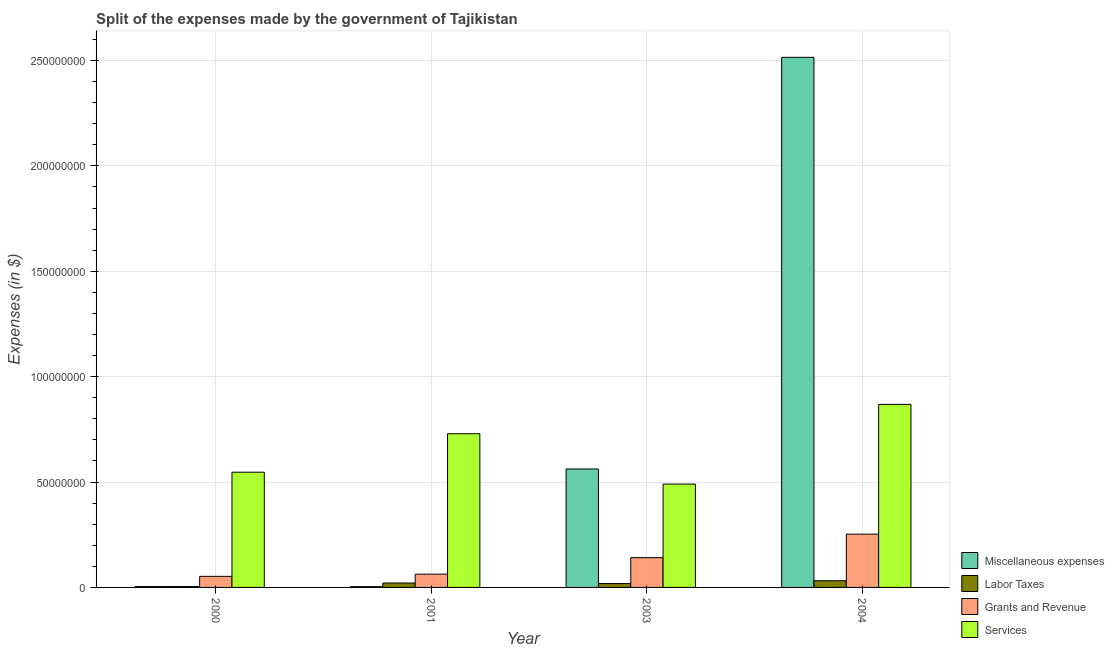How many different coloured bars are there?
Provide a succinct answer. 4. How many groups of bars are there?
Make the answer very short. 4. Are the number of bars per tick equal to the number of legend labels?
Offer a very short reply. Yes. Are the number of bars on each tick of the X-axis equal?
Keep it short and to the point. Yes. How many bars are there on the 4th tick from the right?
Your answer should be very brief. 4. In how many cases, is the number of bars for a given year not equal to the number of legend labels?
Provide a short and direct response. 0. What is the amount spent on services in 2003?
Provide a succinct answer. 4.90e+07. Across all years, what is the maximum amount spent on services?
Offer a terse response. 8.68e+07. Across all years, what is the minimum amount spent on labor taxes?
Provide a succinct answer. 4.11e+05. What is the total amount spent on labor taxes in the graph?
Offer a terse response. 7.50e+06. What is the difference between the amount spent on miscellaneous expenses in 2000 and that in 2004?
Give a very brief answer. -2.51e+08. What is the difference between the amount spent on miscellaneous expenses in 2001 and the amount spent on services in 2000?
Provide a short and direct response. -2.50e+04. What is the average amount spent on services per year?
Provide a short and direct response. 6.59e+07. In the year 2004, what is the difference between the amount spent on services and amount spent on labor taxes?
Provide a short and direct response. 0. What is the ratio of the amount spent on grants and revenue in 2001 to that in 2004?
Make the answer very short. 0.25. Is the difference between the amount spent on labor taxes in 2003 and 2004 greater than the difference between the amount spent on miscellaneous expenses in 2003 and 2004?
Your answer should be very brief. No. What is the difference between the highest and the second highest amount spent on services?
Make the answer very short. 1.39e+07. What is the difference between the highest and the lowest amount spent on labor taxes?
Provide a short and direct response. 2.76e+06. In how many years, is the amount spent on services greater than the average amount spent on services taken over all years?
Ensure brevity in your answer.  2. Is it the case that in every year, the sum of the amount spent on labor taxes and amount spent on grants and revenue is greater than the sum of amount spent on services and amount spent on miscellaneous expenses?
Your answer should be compact. No. What does the 3rd bar from the left in 2000 represents?
Your answer should be very brief. Grants and Revenue. What does the 2nd bar from the right in 2000 represents?
Ensure brevity in your answer.  Grants and Revenue. How many bars are there?
Provide a short and direct response. 16. What is the difference between two consecutive major ticks on the Y-axis?
Provide a short and direct response. 5.00e+07. Where does the legend appear in the graph?
Offer a terse response. Bottom right. How many legend labels are there?
Your answer should be very brief. 4. How are the legend labels stacked?
Your answer should be compact. Vertical. What is the title of the graph?
Ensure brevity in your answer.  Split of the expenses made by the government of Tajikistan. What is the label or title of the X-axis?
Ensure brevity in your answer.  Year. What is the label or title of the Y-axis?
Offer a terse response. Expenses (in $). What is the Expenses (in $) in Miscellaneous expenses in 2000?
Provide a succinct answer. 3.95e+05. What is the Expenses (in $) of Labor Taxes in 2000?
Provide a short and direct response. 4.11e+05. What is the Expenses (in $) in Grants and Revenue in 2000?
Keep it short and to the point. 5.25e+06. What is the Expenses (in $) of Services in 2000?
Offer a terse response. 5.47e+07. What is the Expenses (in $) in Miscellaneous expenses in 2001?
Keep it short and to the point. 3.70e+05. What is the Expenses (in $) of Labor Taxes in 2001?
Keep it short and to the point. 2.09e+06. What is the Expenses (in $) of Grants and Revenue in 2001?
Ensure brevity in your answer.  6.30e+06. What is the Expenses (in $) in Services in 2001?
Offer a very short reply. 7.29e+07. What is the Expenses (in $) in Miscellaneous expenses in 2003?
Give a very brief answer. 5.62e+07. What is the Expenses (in $) in Labor Taxes in 2003?
Offer a very short reply. 1.83e+06. What is the Expenses (in $) of Grants and Revenue in 2003?
Keep it short and to the point. 1.41e+07. What is the Expenses (in $) of Services in 2003?
Provide a short and direct response. 4.90e+07. What is the Expenses (in $) of Miscellaneous expenses in 2004?
Provide a succinct answer. 2.51e+08. What is the Expenses (in $) in Labor Taxes in 2004?
Make the answer very short. 3.17e+06. What is the Expenses (in $) in Grants and Revenue in 2004?
Offer a terse response. 2.53e+07. What is the Expenses (in $) in Services in 2004?
Your answer should be very brief. 8.68e+07. Across all years, what is the maximum Expenses (in $) of Miscellaneous expenses?
Make the answer very short. 2.51e+08. Across all years, what is the maximum Expenses (in $) in Labor Taxes?
Your answer should be compact. 3.17e+06. Across all years, what is the maximum Expenses (in $) in Grants and Revenue?
Offer a very short reply. 2.53e+07. Across all years, what is the maximum Expenses (in $) in Services?
Your answer should be compact. 8.68e+07. Across all years, what is the minimum Expenses (in $) of Labor Taxes?
Keep it short and to the point. 4.11e+05. Across all years, what is the minimum Expenses (in $) in Grants and Revenue?
Make the answer very short. 5.25e+06. Across all years, what is the minimum Expenses (in $) of Services?
Ensure brevity in your answer.  4.90e+07. What is the total Expenses (in $) in Miscellaneous expenses in the graph?
Offer a terse response. 3.08e+08. What is the total Expenses (in $) in Labor Taxes in the graph?
Provide a succinct answer. 7.50e+06. What is the total Expenses (in $) in Grants and Revenue in the graph?
Ensure brevity in your answer.  5.10e+07. What is the total Expenses (in $) in Services in the graph?
Give a very brief answer. 2.63e+08. What is the difference between the Expenses (in $) in Miscellaneous expenses in 2000 and that in 2001?
Offer a very short reply. 2.50e+04. What is the difference between the Expenses (in $) of Labor Taxes in 2000 and that in 2001?
Your response must be concise. -1.68e+06. What is the difference between the Expenses (in $) of Grants and Revenue in 2000 and that in 2001?
Your response must be concise. -1.05e+06. What is the difference between the Expenses (in $) of Services in 2000 and that in 2001?
Ensure brevity in your answer.  -1.82e+07. What is the difference between the Expenses (in $) in Miscellaneous expenses in 2000 and that in 2003?
Your answer should be compact. -5.58e+07. What is the difference between the Expenses (in $) of Labor Taxes in 2000 and that in 2003?
Provide a short and direct response. -1.42e+06. What is the difference between the Expenses (in $) of Grants and Revenue in 2000 and that in 2003?
Your answer should be compact. -8.87e+06. What is the difference between the Expenses (in $) of Services in 2000 and that in 2003?
Provide a short and direct response. 5.65e+06. What is the difference between the Expenses (in $) of Miscellaneous expenses in 2000 and that in 2004?
Ensure brevity in your answer.  -2.51e+08. What is the difference between the Expenses (in $) of Labor Taxes in 2000 and that in 2004?
Offer a very short reply. -2.76e+06. What is the difference between the Expenses (in $) of Grants and Revenue in 2000 and that in 2004?
Ensure brevity in your answer.  -2.00e+07. What is the difference between the Expenses (in $) in Services in 2000 and that in 2004?
Provide a succinct answer. -3.22e+07. What is the difference between the Expenses (in $) in Miscellaneous expenses in 2001 and that in 2003?
Ensure brevity in your answer.  -5.58e+07. What is the difference between the Expenses (in $) of Labor Taxes in 2001 and that in 2003?
Give a very brief answer. 2.58e+05. What is the difference between the Expenses (in $) in Grants and Revenue in 2001 and that in 2003?
Your answer should be compact. -7.82e+06. What is the difference between the Expenses (in $) of Services in 2001 and that in 2003?
Give a very brief answer. 2.39e+07. What is the difference between the Expenses (in $) in Miscellaneous expenses in 2001 and that in 2004?
Make the answer very short. -2.51e+08. What is the difference between the Expenses (in $) in Labor Taxes in 2001 and that in 2004?
Keep it short and to the point. -1.08e+06. What is the difference between the Expenses (in $) of Grants and Revenue in 2001 and that in 2004?
Keep it short and to the point. -1.90e+07. What is the difference between the Expenses (in $) in Services in 2001 and that in 2004?
Ensure brevity in your answer.  -1.39e+07. What is the difference between the Expenses (in $) in Miscellaneous expenses in 2003 and that in 2004?
Ensure brevity in your answer.  -1.95e+08. What is the difference between the Expenses (in $) of Labor Taxes in 2003 and that in 2004?
Give a very brief answer. -1.34e+06. What is the difference between the Expenses (in $) in Grants and Revenue in 2003 and that in 2004?
Keep it short and to the point. -1.12e+07. What is the difference between the Expenses (in $) in Services in 2003 and that in 2004?
Your response must be concise. -3.78e+07. What is the difference between the Expenses (in $) in Miscellaneous expenses in 2000 and the Expenses (in $) in Labor Taxes in 2001?
Your response must be concise. -1.69e+06. What is the difference between the Expenses (in $) of Miscellaneous expenses in 2000 and the Expenses (in $) of Grants and Revenue in 2001?
Your response must be concise. -5.90e+06. What is the difference between the Expenses (in $) of Miscellaneous expenses in 2000 and the Expenses (in $) of Services in 2001?
Your answer should be very brief. -7.25e+07. What is the difference between the Expenses (in $) of Labor Taxes in 2000 and the Expenses (in $) of Grants and Revenue in 2001?
Provide a short and direct response. -5.89e+06. What is the difference between the Expenses (in $) in Labor Taxes in 2000 and the Expenses (in $) in Services in 2001?
Your answer should be compact. -7.25e+07. What is the difference between the Expenses (in $) of Grants and Revenue in 2000 and the Expenses (in $) of Services in 2001?
Give a very brief answer. -6.77e+07. What is the difference between the Expenses (in $) of Miscellaneous expenses in 2000 and the Expenses (in $) of Labor Taxes in 2003?
Make the answer very short. -1.43e+06. What is the difference between the Expenses (in $) of Miscellaneous expenses in 2000 and the Expenses (in $) of Grants and Revenue in 2003?
Provide a succinct answer. -1.37e+07. What is the difference between the Expenses (in $) in Miscellaneous expenses in 2000 and the Expenses (in $) in Services in 2003?
Give a very brief answer. -4.86e+07. What is the difference between the Expenses (in $) in Labor Taxes in 2000 and the Expenses (in $) in Grants and Revenue in 2003?
Give a very brief answer. -1.37e+07. What is the difference between the Expenses (in $) of Labor Taxes in 2000 and the Expenses (in $) of Services in 2003?
Your answer should be very brief. -4.86e+07. What is the difference between the Expenses (in $) in Grants and Revenue in 2000 and the Expenses (in $) in Services in 2003?
Make the answer very short. -4.38e+07. What is the difference between the Expenses (in $) in Miscellaneous expenses in 2000 and the Expenses (in $) in Labor Taxes in 2004?
Your answer should be very brief. -2.78e+06. What is the difference between the Expenses (in $) in Miscellaneous expenses in 2000 and the Expenses (in $) in Grants and Revenue in 2004?
Make the answer very short. -2.49e+07. What is the difference between the Expenses (in $) of Miscellaneous expenses in 2000 and the Expenses (in $) of Services in 2004?
Give a very brief answer. -8.64e+07. What is the difference between the Expenses (in $) in Labor Taxes in 2000 and the Expenses (in $) in Grants and Revenue in 2004?
Offer a very short reply. -2.49e+07. What is the difference between the Expenses (in $) in Labor Taxes in 2000 and the Expenses (in $) in Services in 2004?
Give a very brief answer. -8.64e+07. What is the difference between the Expenses (in $) of Grants and Revenue in 2000 and the Expenses (in $) of Services in 2004?
Give a very brief answer. -8.16e+07. What is the difference between the Expenses (in $) in Miscellaneous expenses in 2001 and the Expenses (in $) in Labor Taxes in 2003?
Give a very brief answer. -1.46e+06. What is the difference between the Expenses (in $) of Miscellaneous expenses in 2001 and the Expenses (in $) of Grants and Revenue in 2003?
Your response must be concise. -1.38e+07. What is the difference between the Expenses (in $) in Miscellaneous expenses in 2001 and the Expenses (in $) in Services in 2003?
Keep it short and to the point. -4.86e+07. What is the difference between the Expenses (in $) of Labor Taxes in 2001 and the Expenses (in $) of Grants and Revenue in 2003?
Ensure brevity in your answer.  -1.20e+07. What is the difference between the Expenses (in $) of Labor Taxes in 2001 and the Expenses (in $) of Services in 2003?
Your answer should be compact. -4.69e+07. What is the difference between the Expenses (in $) in Grants and Revenue in 2001 and the Expenses (in $) in Services in 2003?
Offer a terse response. -4.27e+07. What is the difference between the Expenses (in $) of Miscellaneous expenses in 2001 and the Expenses (in $) of Labor Taxes in 2004?
Your answer should be very brief. -2.80e+06. What is the difference between the Expenses (in $) in Miscellaneous expenses in 2001 and the Expenses (in $) in Grants and Revenue in 2004?
Ensure brevity in your answer.  -2.49e+07. What is the difference between the Expenses (in $) in Miscellaneous expenses in 2001 and the Expenses (in $) in Services in 2004?
Provide a short and direct response. -8.65e+07. What is the difference between the Expenses (in $) in Labor Taxes in 2001 and the Expenses (in $) in Grants and Revenue in 2004?
Your response must be concise. -2.32e+07. What is the difference between the Expenses (in $) in Labor Taxes in 2001 and the Expenses (in $) in Services in 2004?
Provide a short and direct response. -8.48e+07. What is the difference between the Expenses (in $) of Grants and Revenue in 2001 and the Expenses (in $) of Services in 2004?
Offer a very short reply. -8.05e+07. What is the difference between the Expenses (in $) in Miscellaneous expenses in 2003 and the Expenses (in $) in Labor Taxes in 2004?
Your answer should be very brief. 5.30e+07. What is the difference between the Expenses (in $) in Miscellaneous expenses in 2003 and the Expenses (in $) in Grants and Revenue in 2004?
Your answer should be compact. 3.09e+07. What is the difference between the Expenses (in $) of Miscellaneous expenses in 2003 and the Expenses (in $) of Services in 2004?
Ensure brevity in your answer.  -3.07e+07. What is the difference between the Expenses (in $) of Labor Taxes in 2003 and the Expenses (in $) of Grants and Revenue in 2004?
Keep it short and to the point. -2.34e+07. What is the difference between the Expenses (in $) of Labor Taxes in 2003 and the Expenses (in $) of Services in 2004?
Provide a succinct answer. -8.50e+07. What is the difference between the Expenses (in $) in Grants and Revenue in 2003 and the Expenses (in $) in Services in 2004?
Give a very brief answer. -7.27e+07. What is the average Expenses (in $) in Miscellaneous expenses per year?
Provide a short and direct response. 7.71e+07. What is the average Expenses (in $) of Labor Taxes per year?
Offer a very short reply. 1.87e+06. What is the average Expenses (in $) of Grants and Revenue per year?
Your answer should be very brief. 1.27e+07. What is the average Expenses (in $) in Services per year?
Keep it short and to the point. 6.59e+07. In the year 2000, what is the difference between the Expenses (in $) of Miscellaneous expenses and Expenses (in $) of Labor Taxes?
Your response must be concise. -1.60e+04. In the year 2000, what is the difference between the Expenses (in $) in Miscellaneous expenses and Expenses (in $) in Grants and Revenue?
Keep it short and to the point. -4.86e+06. In the year 2000, what is the difference between the Expenses (in $) in Miscellaneous expenses and Expenses (in $) in Services?
Make the answer very short. -5.43e+07. In the year 2000, what is the difference between the Expenses (in $) in Labor Taxes and Expenses (in $) in Grants and Revenue?
Provide a short and direct response. -4.84e+06. In the year 2000, what is the difference between the Expenses (in $) in Labor Taxes and Expenses (in $) in Services?
Offer a very short reply. -5.43e+07. In the year 2000, what is the difference between the Expenses (in $) in Grants and Revenue and Expenses (in $) in Services?
Keep it short and to the point. -4.94e+07. In the year 2001, what is the difference between the Expenses (in $) of Miscellaneous expenses and Expenses (in $) of Labor Taxes?
Your response must be concise. -1.72e+06. In the year 2001, what is the difference between the Expenses (in $) in Miscellaneous expenses and Expenses (in $) in Grants and Revenue?
Your answer should be compact. -5.93e+06. In the year 2001, what is the difference between the Expenses (in $) of Miscellaneous expenses and Expenses (in $) of Services?
Provide a short and direct response. -7.25e+07. In the year 2001, what is the difference between the Expenses (in $) in Labor Taxes and Expenses (in $) in Grants and Revenue?
Offer a terse response. -4.21e+06. In the year 2001, what is the difference between the Expenses (in $) of Labor Taxes and Expenses (in $) of Services?
Provide a short and direct response. -7.08e+07. In the year 2001, what is the difference between the Expenses (in $) in Grants and Revenue and Expenses (in $) in Services?
Provide a succinct answer. -6.66e+07. In the year 2003, what is the difference between the Expenses (in $) of Miscellaneous expenses and Expenses (in $) of Labor Taxes?
Ensure brevity in your answer.  5.44e+07. In the year 2003, what is the difference between the Expenses (in $) in Miscellaneous expenses and Expenses (in $) in Grants and Revenue?
Offer a very short reply. 4.21e+07. In the year 2003, what is the difference between the Expenses (in $) in Miscellaneous expenses and Expenses (in $) in Services?
Give a very brief answer. 7.16e+06. In the year 2003, what is the difference between the Expenses (in $) in Labor Taxes and Expenses (in $) in Grants and Revenue?
Provide a succinct answer. -1.23e+07. In the year 2003, what is the difference between the Expenses (in $) in Labor Taxes and Expenses (in $) in Services?
Your response must be concise. -4.72e+07. In the year 2003, what is the difference between the Expenses (in $) of Grants and Revenue and Expenses (in $) of Services?
Provide a succinct answer. -3.49e+07. In the year 2004, what is the difference between the Expenses (in $) in Miscellaneous expenses and Expenses (in $) in Labor Taxes?
Keep it short and to the point. 2.48e+08. In the year 2004, what is the difference between the Expenses (in $) of Miscellaneous expenses and Expenses (in $) of Grants and Revenue?
Make the answer very short. 2.26e+08. In the year 2004, what is the difference between the Expenses (in $) in Miscellaneous expenses and Expenses (in $) in Services?
Offer a very short reply. 1.65e+08. In the year 2004, what is the difference between the Expenses (in $) in Labor Taxes and Expenses (in $) in Grants and Revenue?
Keep it short and to the point. -2.21e+07. In the year 2004, what is the difference between the Expenses (in $) in Labor Taxes and Expenses (in $) in Services?
Provide a short and direct response. -8.37e+07. In the year 2004, what is the difference between the Expenses (in $) of Grants and Revenue and Expenses (in $) of Services?
Provide a short and direct response. -6.16e+07. What is the ratio of the Expenses (in $) in Miscellaneous expenses in 2000 to that in 2001?
Your answer should be very brief. 1.07. What is the ratio of the Expenses (in $) of Labor Taxes in 2000 to that in 2001?
Provide a succinct answer. 0.2. What is the ratio of the Expenses (in $) of Grants and Revenue in 2000 to that in 2001?
Give a very brief answer. 0.83. What is the ratio of the Expenses (in $) of Services in 2000 to that in 2001?
Provide a succinct answer. 0.75. What is the ratio of the Expenses (in $) of Miscellaneous expenses in 2000 to that in 2003?
Provide a succinct answer. 0.01. What is the ratio of the Expenses (in $) of Labor Taxes in 2000 to that in 2003?
Offer a terse response. 0.22. What is the ratio of the Expenses (in $) of Grants and Revenue in 2000 to that in 2003?
Your response must be concise. 0.37. What is the ratio of the Expenses (in $) in Services in 2000 to that in 2003?
Provide a succinct answer. 1.12. What is the ratio of the Expenses (in $) in Miscellaneous expenses in 2000 to that in 2004?
Provide a short and direct response. 0. What is the ratio of the Expenses (in $) in Labor Taxes in 2000 to that in 2004?
Make the answer very short. 0.13. What is the ratio of the Expenses (in $) of Grants and Revenue in 2000 to that in 2004?
Your answer should be very brief. 0.21. What is the ratio of the Expenses (in $) of Services in 2000 to that in 2004?
Make the answer very short. 0.63. What is the ratio of the Expenses (in $) of Miscellaneous expenses in 2001 to that in 2003?
Your response must be concise. 0.01. What is the ratio of the Expenses (in $) in Labor Taxes in 2001 to that in 2003?
Ensure brevity in your answer.  1.14. What is the ratio of the Expenses (in $) of Grants and Revenue in 2001 to that in 2003?
Your response must be concise. 0.45. What is the ratio of the Expenses (in $) in Services in 2001 to that in 2003?
Keep it short and to the point. 1.49. What is the ratio of the Expenses (in $) in Miscellaneous expenses in 2001 to that in 2004?
Provide a succinct answer. 0. What is the ratio of the Expenses (in $) in Labor Taxes in 2001 to that in 2004?
Your answer should be compact. 0.66. What is the ratio of the Expenses (in $) of Grants and Revenue in 2001 to that in 2004?
Your answer should be very brief. 0.25. What is the ratio of the Expenses (in $) of Services in 2001 to that in 2004?
Provide a short and direct response. 0.84. What is the ratio of the Expenses (in $) in Miscellaneous expenses in 2003 to that in 2004?
Your answer should be very brief. 0.22. What is the ratio of the Expenses (in $) of Labor Taxes in 2003 to that in 2004?
Your answer should be very brief. 0.58. What is the ratio of the Expenses (in $) of Grants and Revenue in 2003 to that in 2004?
Offer a very short reply. 0.56. What is the ratio of the Expenses (in $) of Services in 2003 to that in 2004?
Provide a short and direct response. 0.56. What is the difference between the highest and the second highest Expenses (in $) of Miscellaneous expenses?
Give a very brief answer. 1.95e+08. What is the difference between the highest and the second highest Expenses (in $) in Labor Taxes?
Offer a terse response. 1.08e+06. What is the difference between the highest and the second highest Expenses (in $) in Grants and Revenue?
Your response must be concise. 1.12e+07. What is the difference between the highest and the second highest Expenses (in $) of Services?
Give a very brief answer. 1.39e+07. What is the difference between the highest and the lowest Expenses (in $) of Miscellaneous expenses?
Provide a short and direct response. 2.51e+08. What is the difference between the highest and the lowest Expenses (in $) of Labor Taxes?
Offer a very short reply. 2.76e+06. What is the difference between the highest and the lowest Expenses (in $) of Grants and Revenue?
Give a very brief answer. 2.00e+07. What is the difference between the highest and the lowest Expenses (in $) in Services?
Offer a terse response. 3.78e+07. 